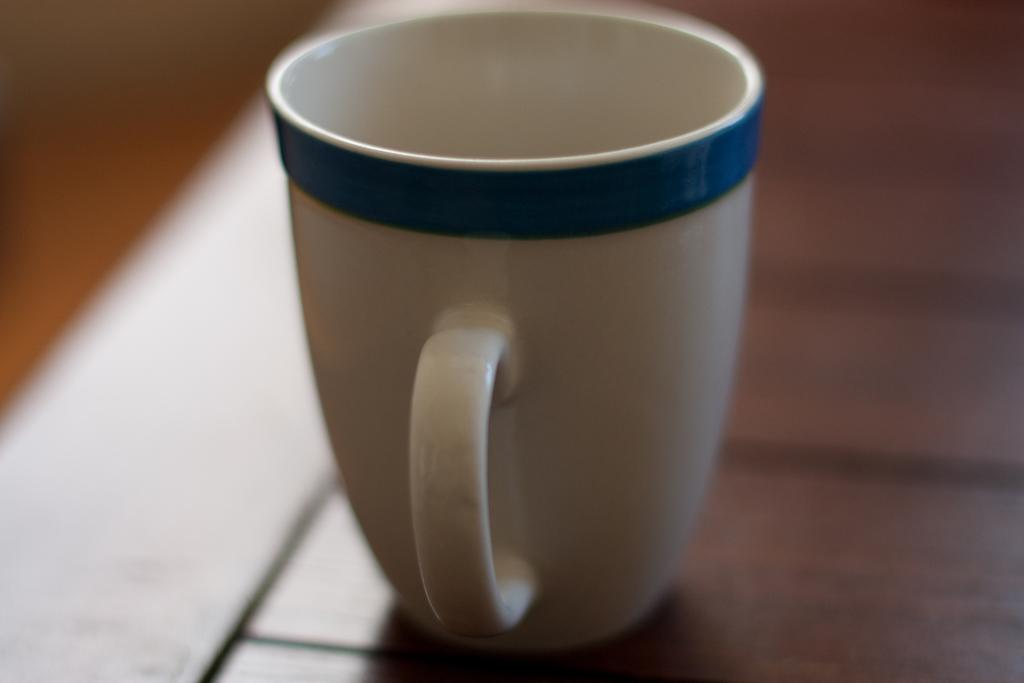What is present in the image that can hold liquids? There is a cup in the image that can hold liquids. What colors are visible on the cup? The cup has a white and blue color. What type of material is the object supporting the cup made of? The cup is on a wooden object. What type of truck is visible in the image? There is no truck present in the image. What scientific theory can be observed in the image? There is no scientific theory depicted in the image. 